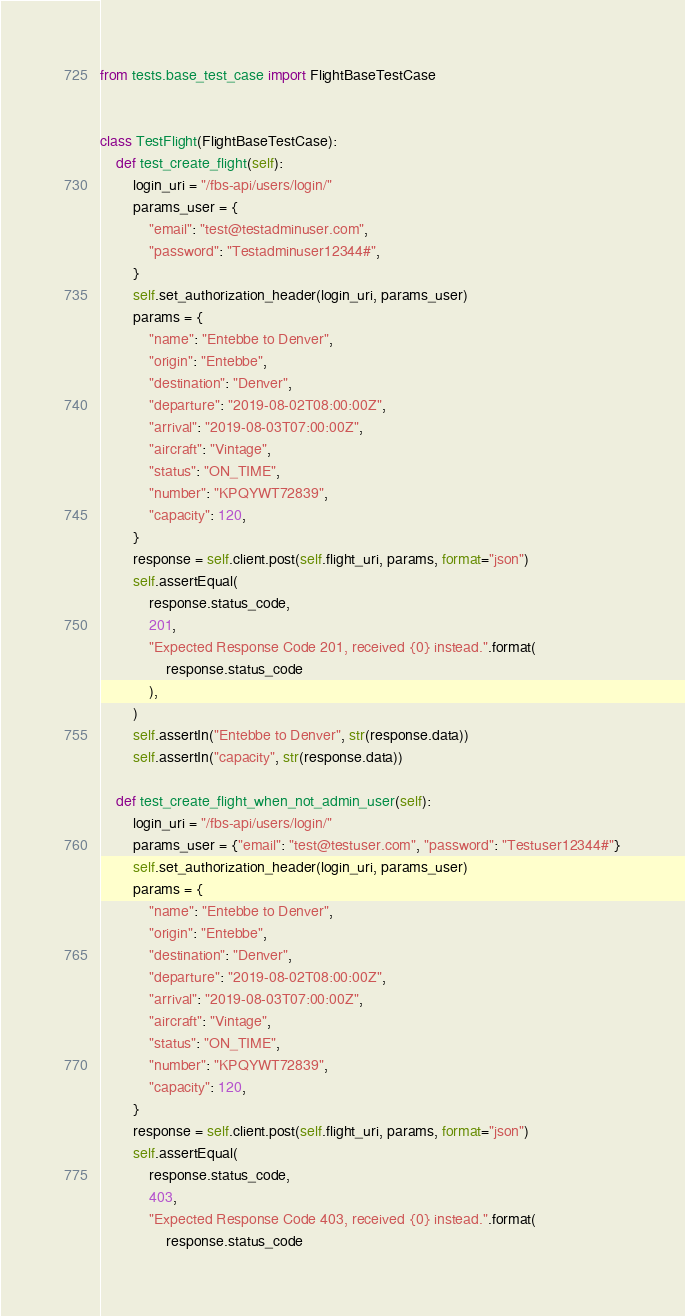<code> <loc_0><loc_0><loc_500><loc_500><_Python_>from tests.base_test_case import FlightBaseTestCase


class TestFlight(FlightBaseTestCase):
    def test_create_flight(self):
        login_uri = "/fbs-api/users/login/"
        params_user = {
            "email": "test@testadminuser.com",
            "password": "Testadminuser12344#",
        }
        self.set_authorization_header(login_uri, params_user)
        params = {
            "name": "Entebbe to Denver",
            "origin": "Entebbe",
            "destination": "Denver",
            "departure": "2019-08-02T08:00:00Z",
            "arrival": "2019-08-03T07:00:00Z",
            "aircraft": "Vintage",
            "status": "ON_TIME",
            "number": "KPQYWT72839",
            "capacity": 120,
        }
        response = self.client.post(self.flight_uri, params, format="json")
        self.assertEqual(
            response.status_code,
            201,
            "Expected Response Code 201, received {0} instead.".format(
                response.status_code
            ),
        )
        self.assertIn("Entebbe to Denver", str(response.data))
        self.assertIn("capacity", str(response.data))

    def test_create_flight_when_not_admin_user(self):
        login_uri = "/fbs-api/users/login/"
        params_user = {"email": "test@testuser.com", "password": "Testuser12344#"}
        self.set_authorization_header(login_uri, params_user)
        params = {
            "name": "Entebbe to Denver",
            "origin": "Entebbe",
            "destination": "Denver",
            "departure": "2019-08-02T08:00:00Z",
            "arrival": "2019-08-03T07:00:00Z",
            "aircraft": "Vintage",
            "status": "ON_TIME",
            "number": "KPQYWT72839",
            "capacity": 120,
        }
        response = self.client.post(self.flight_uri, params, format="json")
        self.assertEqual(
            response.status_code,
            403,
            "Expected Response Code 403, received {0} instead.".format(
                response.status_code</code> 